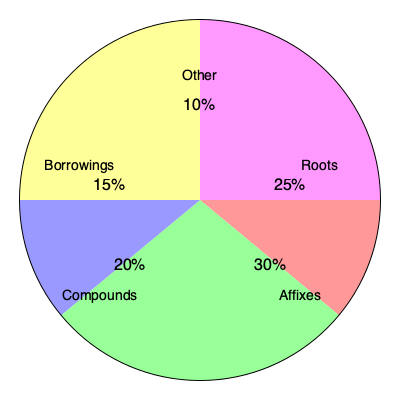Based on the pie chart depicting the structure of Esperanto vocabulary, which component represents the largest portion of the language's lexicon? To determine the largest component of Esperanto vocabulary, we need to compare the percentages given in the pie chart:

1. Roots: 25%
2. Affixes: 30%
3. Compounds: 20%
4. Borrowings: 15%
5. Other: 10%

By comparing these percentages, we can see that Affixes have the largest share at 30%. This reflects the agglutinative nature of Esperanto, where affixes play a crucial role in word formation and expanding the vocabulary.

The importance of affixes in Esperanto aligns with the language's design principle of regularity and productivity. Affixes allow speakers to create new words and modify existing ones systematically, contributing to the language's flexibility and expressiveness.
Answer: Affixes (30%) 